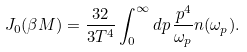<formula> <loc_0><loc_0><loc_500><loc_500>J _ { 0 } ( \beta M ) = \frac { 3 2 } { 3 T ^ { 4 } } \int _ { 0 } ^ { \infty } d p \, \frac { p ^ { 4 } } { \omega _ { p } } n ( \omega _ { p } ) .</formula> 